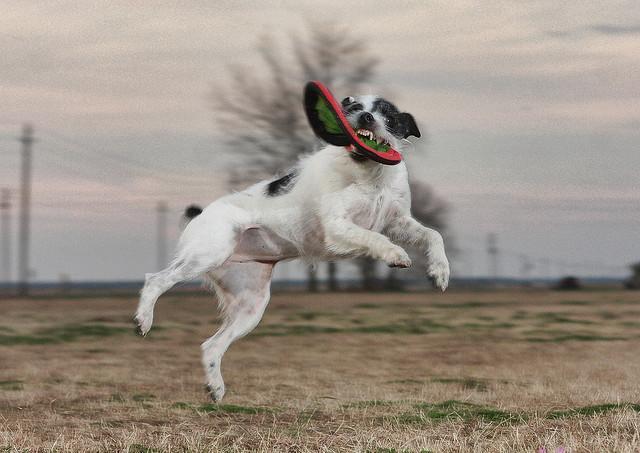How many dogs?
Give a very brief answer. 1. How many of the dogs feet are touching the ground?
Give a very brief answer. 0. 